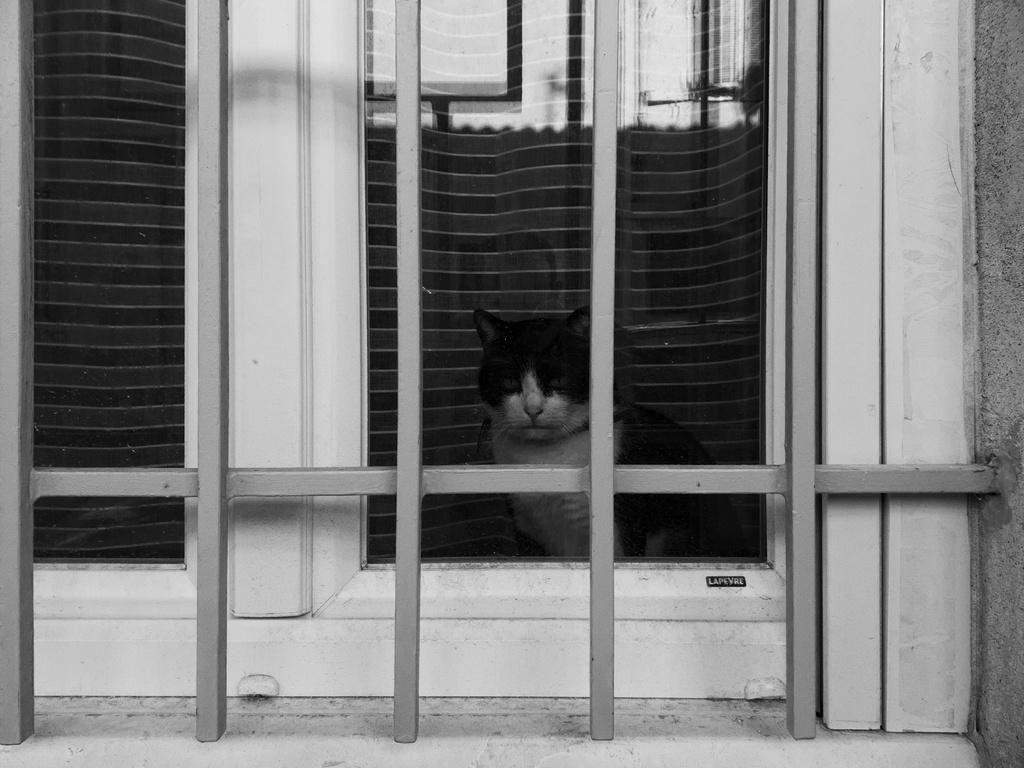Could you give a brief overview of what you see in this image? In this black and white image, we can see a cat in front of the window. 